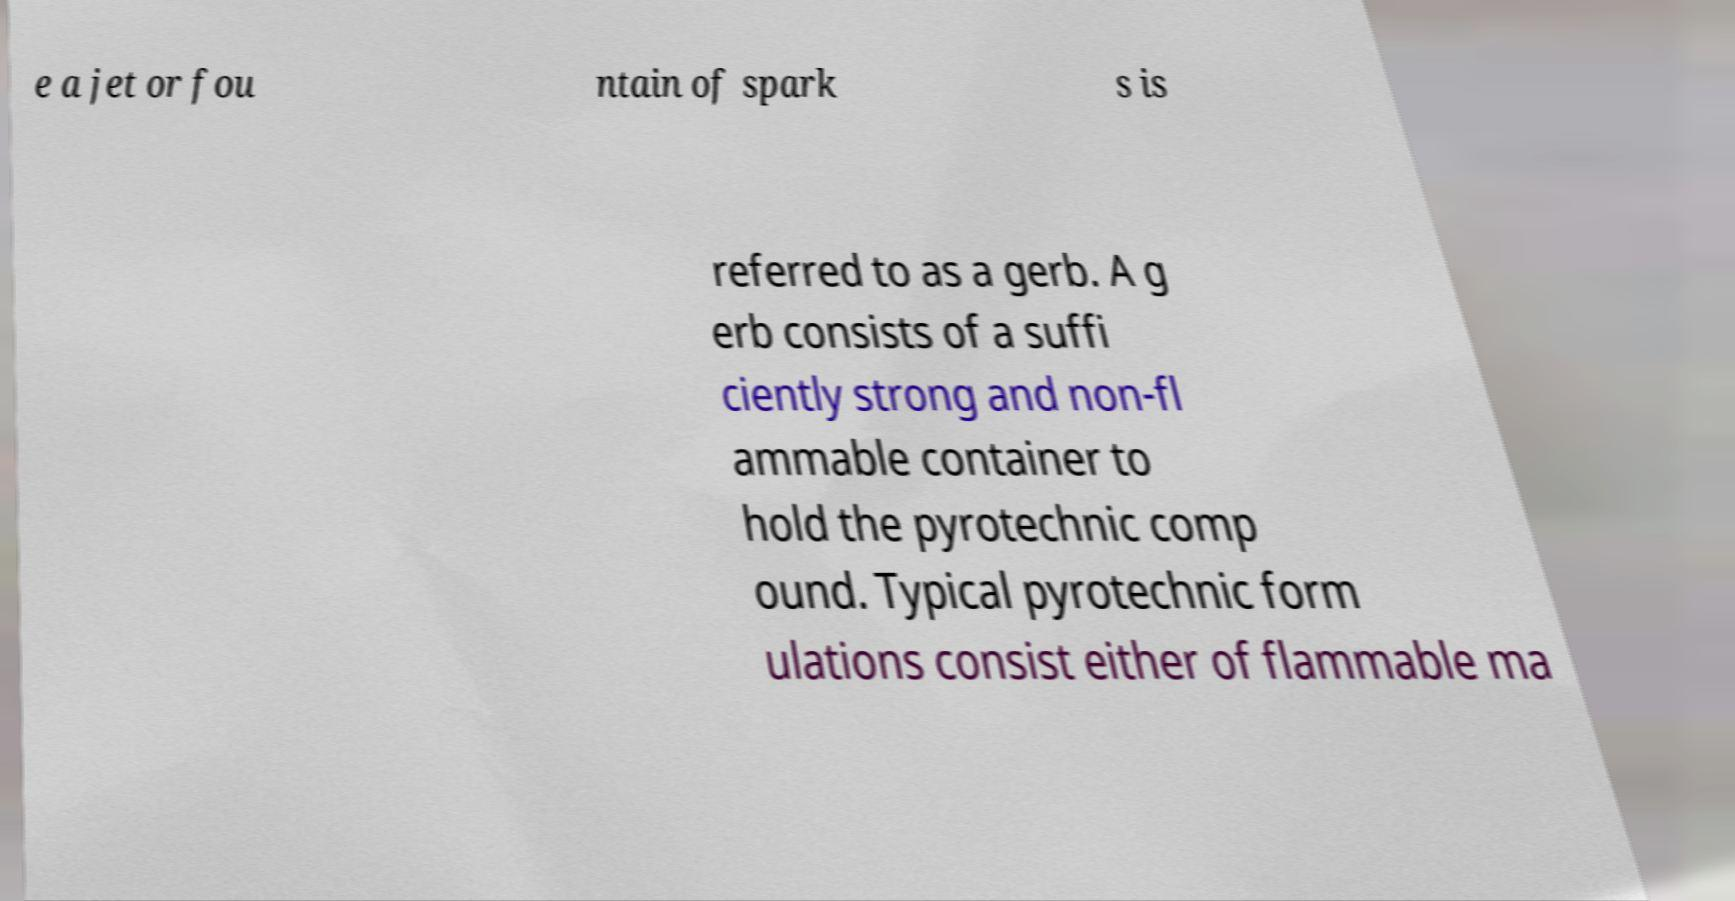Can you accurately transcribe the text from the provided image for me? e a jet or fou ntain of spark s is referred to as a gerb. A g erb consists of a suffi ciently strong and non-fl ammable container to hold the pyrotechnic comp ound. Typical pyrotechnic form ulations consist either of flammable ma 